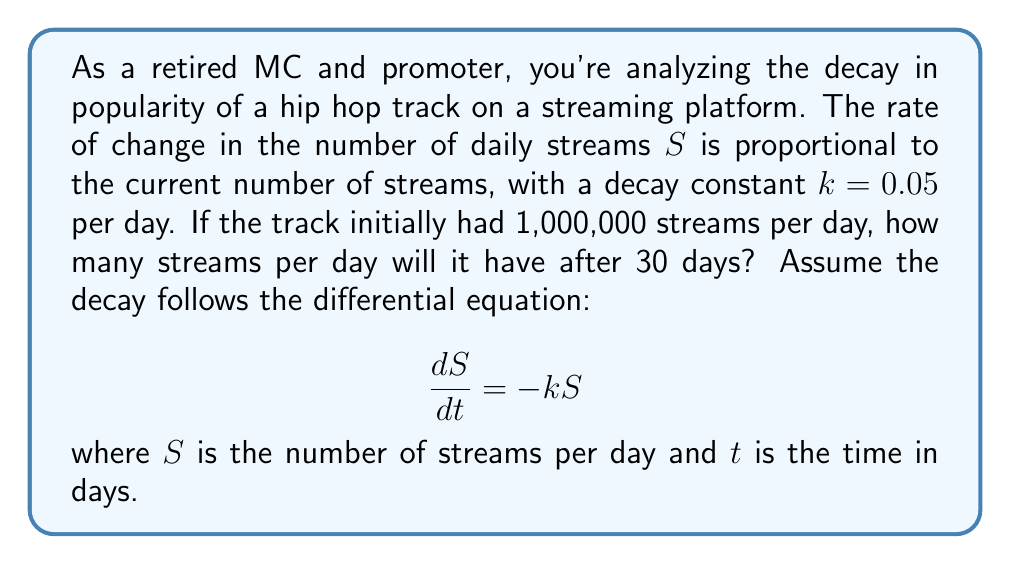Can you solve this math problem? Let's solve this first-order differential equation step by step:

1) The general solution for this type of differential equation is:
   $$S(t) = S_0e^{-kt}$$
   where $S_0$ is the initial number of streams.

2) We're given:
   $S_0 = 1,000,000$ streams/day
   $k = 0.05$ per day
   $t = 30$ days

3) Plugging these values into our solution:
   $$S(30) = 1,000,000 \cdot e^{-0.05 \cdot 30}$$

4) Simplify:
   $$S(30) = 1,000,000 \cdot e^{-1.5}$$

5) Calculate:
   $$S(30) = 1,000,000 \cdot 0.22313$$
   $$S(30) = 223,130$$ (rounded to nearest whole number)

Therefore, after 30 days, the track will have approximately 223,130 streams per day.
Answer: 223,130 streams per day 